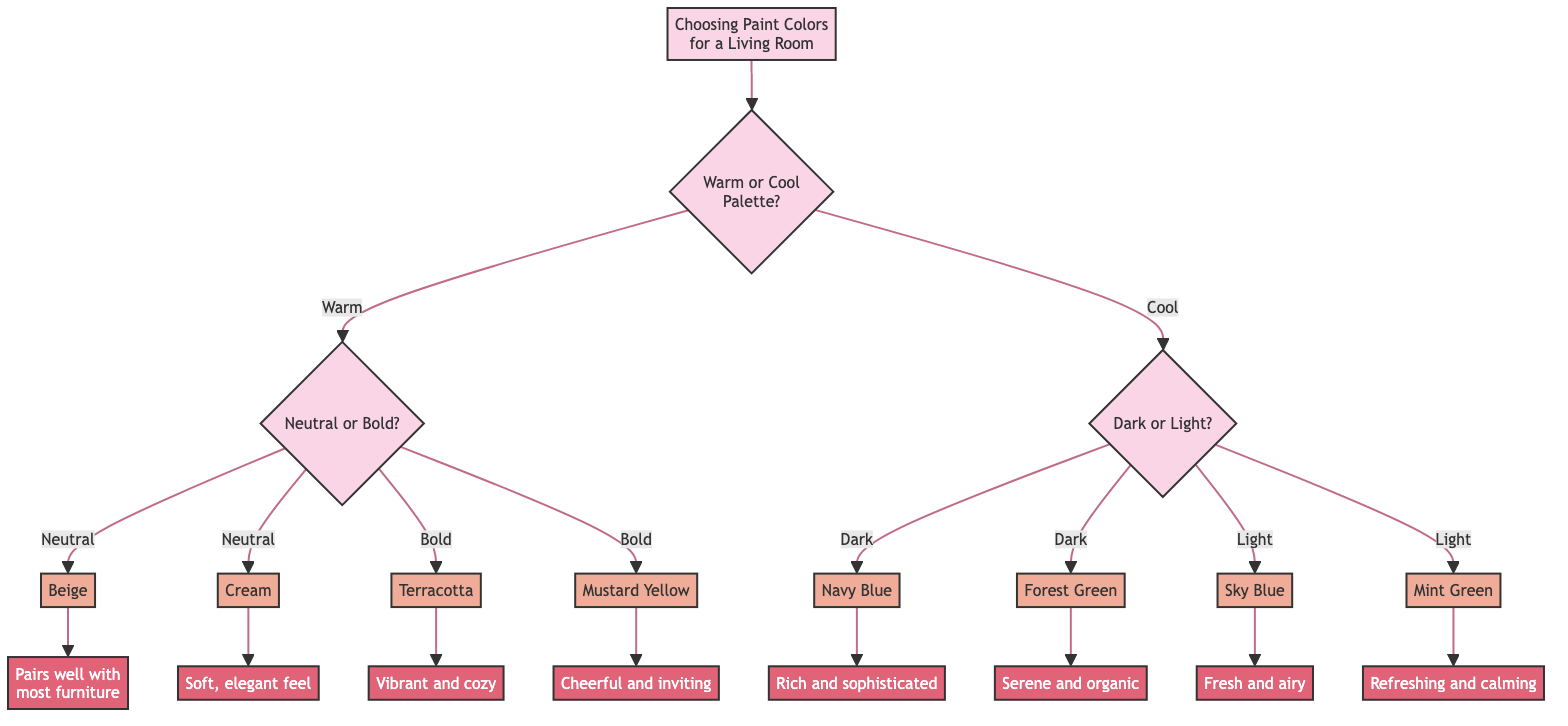What is the first question in the decision tree? The first question in the decision tree is about the preference for a warm or cool palette. This is indicated as the first decision point after the title.
Answer: Warm or Cool Palette? How many options are available after choosing a warm palette? After choosing a warm palette, there are two options available: Neutral and Bold. This is seen in the next branching after the warm selection.
Answer: 2 What decision follows the choice of Mustard Yellow? The choice of Mustard Yellow leads to the decision: "Mustard Yellow creates a cheerful and inviting atmosphere." This is the response tied to the selection of the bold color Mustard Yellow.
Answer: Cheerful and inviting atmosphere If a user selects Light color, what are their color options? If a user selects Light color, their options are Sky Blue and Mint Green. This is found in the part of the diagram that branches off from the Light selection.
Answer: Sky Blue, Mint Green What are the two dark colors available? The two dark color options available are Navy Blue and Forest Green. This is depicted after selecting the Dark option from the Cool palette section.
Answer: Navy Blue, Forest Green What color is associated with a serene atmosphere? The color associated with a serene atmosphere is Forest Green, which is a choice under the Dark colors. This is explicitly stated in the decision linked to Forest Green.
Answer: Forest Green How many color choices respond to a Neutral warm preference? There are two color choices that respond to a Neutral warm preference: Beige and Cream. This is indicated in the branching immediately after the Neutral selection.
Answer: 2 